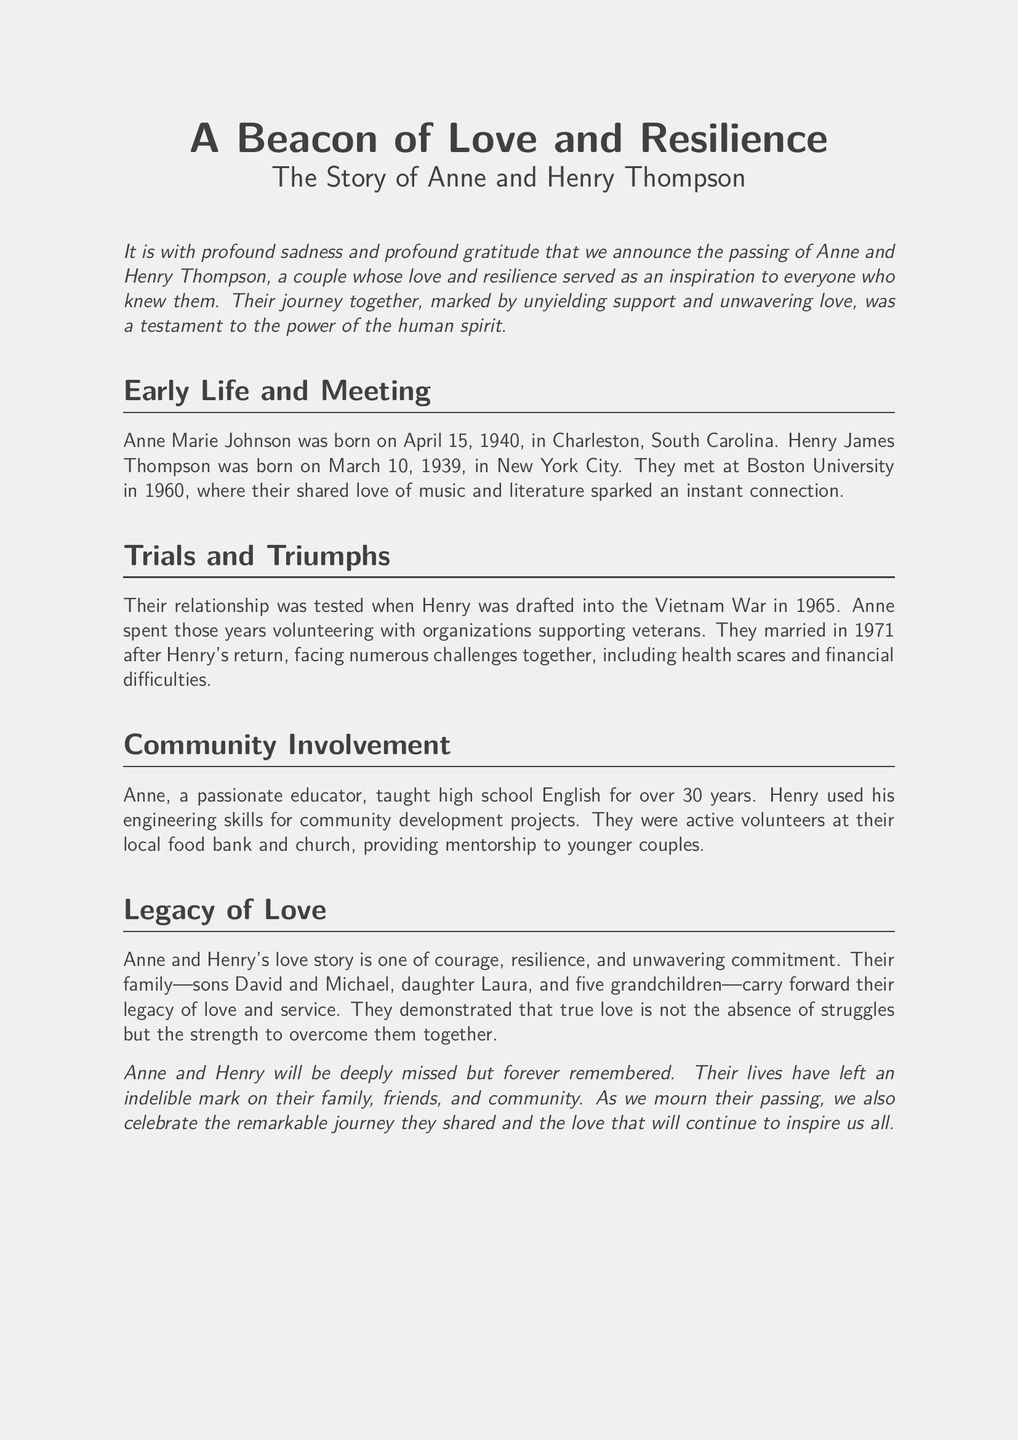What are the birth dates of Anne and Henry? The document states that Anne was born on April 15, 1940, and Henry was born on March 10, 1939.
Answer: April 15, 1940, and March 10, 1939 In which year did Anne and Henry meet? Anne and Henry met at Boston University in 1960.
Answer: 1960 What major life event happened to Henry in 1965? The document mentions that Henry was drafted into the Vietnam War in 1965.
Answer: Drafted into the Vietnam War Who are the children of Anne and Henry? The obituary lists their children as David, Michael, and Laura.
Answer: David, Michael, and Laura What was Anne's profession? The document indicates that Anne was a high school English teacher for over 30 years.
Answer: High school English teacher How many grandchildren did Anne and Henry have? The document states that they had five grandchildren.
Answer: Five What did Anne do while Henry was serving in the war? It mentions that Anne spent those years volunteering with organizations supporting veterans.
Answer: Volunteering with veterans What was the couple's legacy? The obituary describes their legacy as one of love and service, carried forward by their family.
Answer: Love and service What role did Henry play in community development? The document states that Henry used his engineering skills for community development projects.
Answer: Engineering skills for community development 